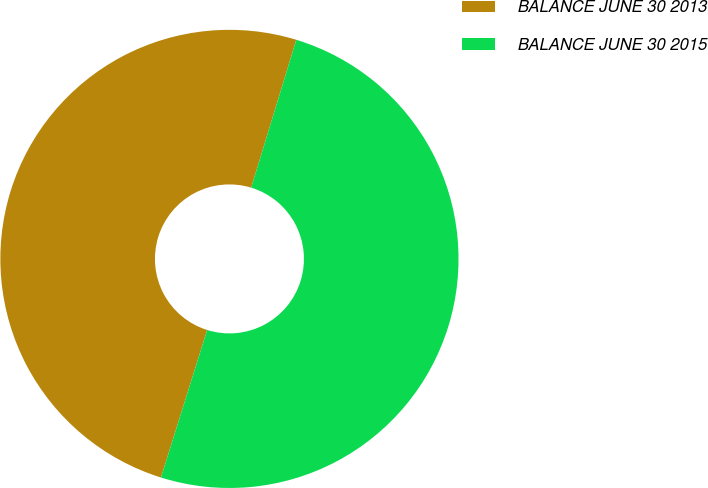<chart> <loc_0><loc_0><loc_500><loc_500><pie_chart><fcel>BALANCE JUNE 30 2013<fcel>BALANCE JUNE 30 2015<nl><fcel>49.88%<fcel>50.12%<nl></chart> 